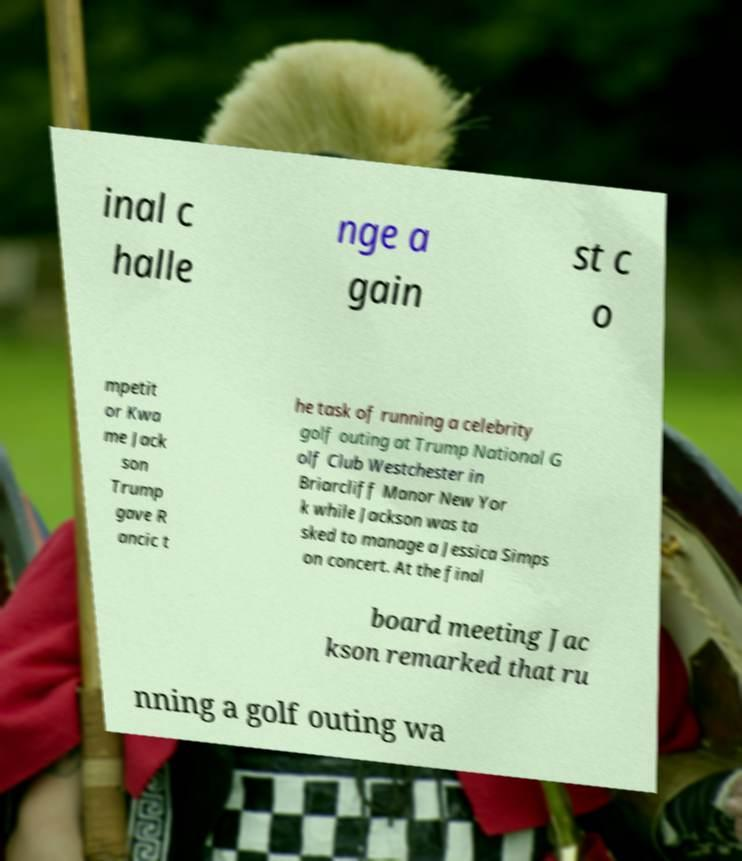For documentation purposes, I need the text within this image transcribed. Could you provide that? inal c halle nge a gain st c o mpetit or Kwa me Jack son Trump gave R ancic t he task of running a celebrity golf outing at Trump National G olf Club Westchester in Briarcliff Manor New Yor k while Jackson was ta sked to manage a Jessica Simps on concert. At the final board meeting Jac kson remarked that ru nning a golf outing wa 